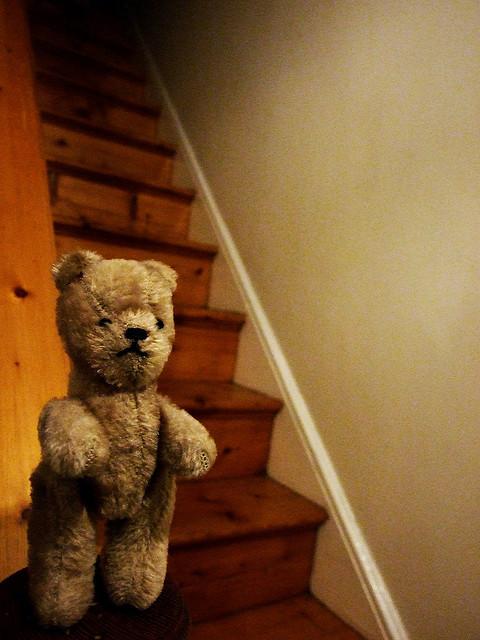What position is the bear in?
Be succinct. Standing. Is there a knot in the wood on the stair rail?
Give a very brief answer. Yes. Are there any people walking down the stairs?
Short answer required. No. 